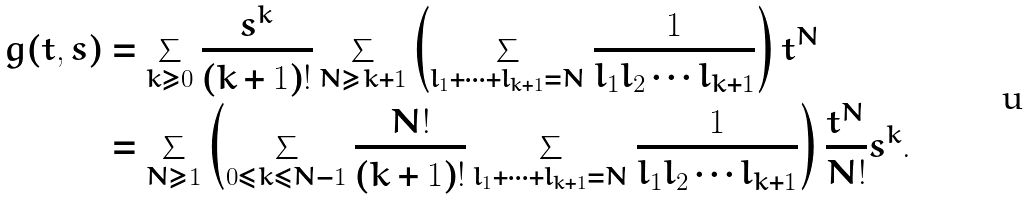<formula> <loc_0><loc_0><loc_500><loc_500>g ( t , s ) & = \sum _ { k \geq 0 } \frac { s ^ { k } } { ( k + 1 ) ! } \sum _ { N \geq k + 1 } \left ( \sum _ { l _ { 1 } + \cdots + l _ { k + 1 } = N } \frac { 1 } { l _ { 1 } l _ { 2 } \cdots l _ { k + 1 } } \right ) t ^ { N } \\ & = \sum _ { N \geq 1 } \left ( \sum _ { 0 \leq k \leq N - 1 } \frac { N ! } { ( k + 1 ) ! } \sum _ { l _ { 1 } + \cdots + l _ { k + 1 } = N } \frac { 1 } { l _ { 1 } l _ { 2 } \cdots l _ { k + 1 } } \right ) \frac { t ^ { N } } { N ! } s ^ { k } .</formula> 